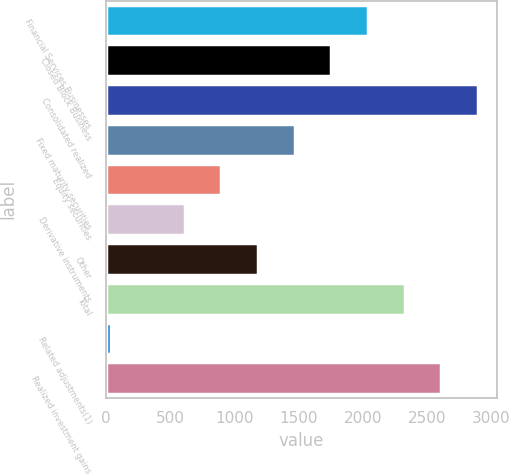Convert chart. <chart><loc_0><loc_0><loc_500><loc_500><bar_chart><fcel>Financial Services Businesses<fcel>Closed Block Business<fcel>Consolidated realized<fcel>Fixed maturity securities<fcel>Equity securities<fcel>Derivative instruments<fcel>Other<fcel>Total<fcel>Related adjustments(1)<fcel>Realized investment gains<nl><fcel>2039.2<fcel>1753.6<fcel>2896<fcel>1468<fcel>896.8<fcel>611.2<fcel>1182.4<fcel>2324.8<fcel>40<fcel>2610.4<nl></chart> 